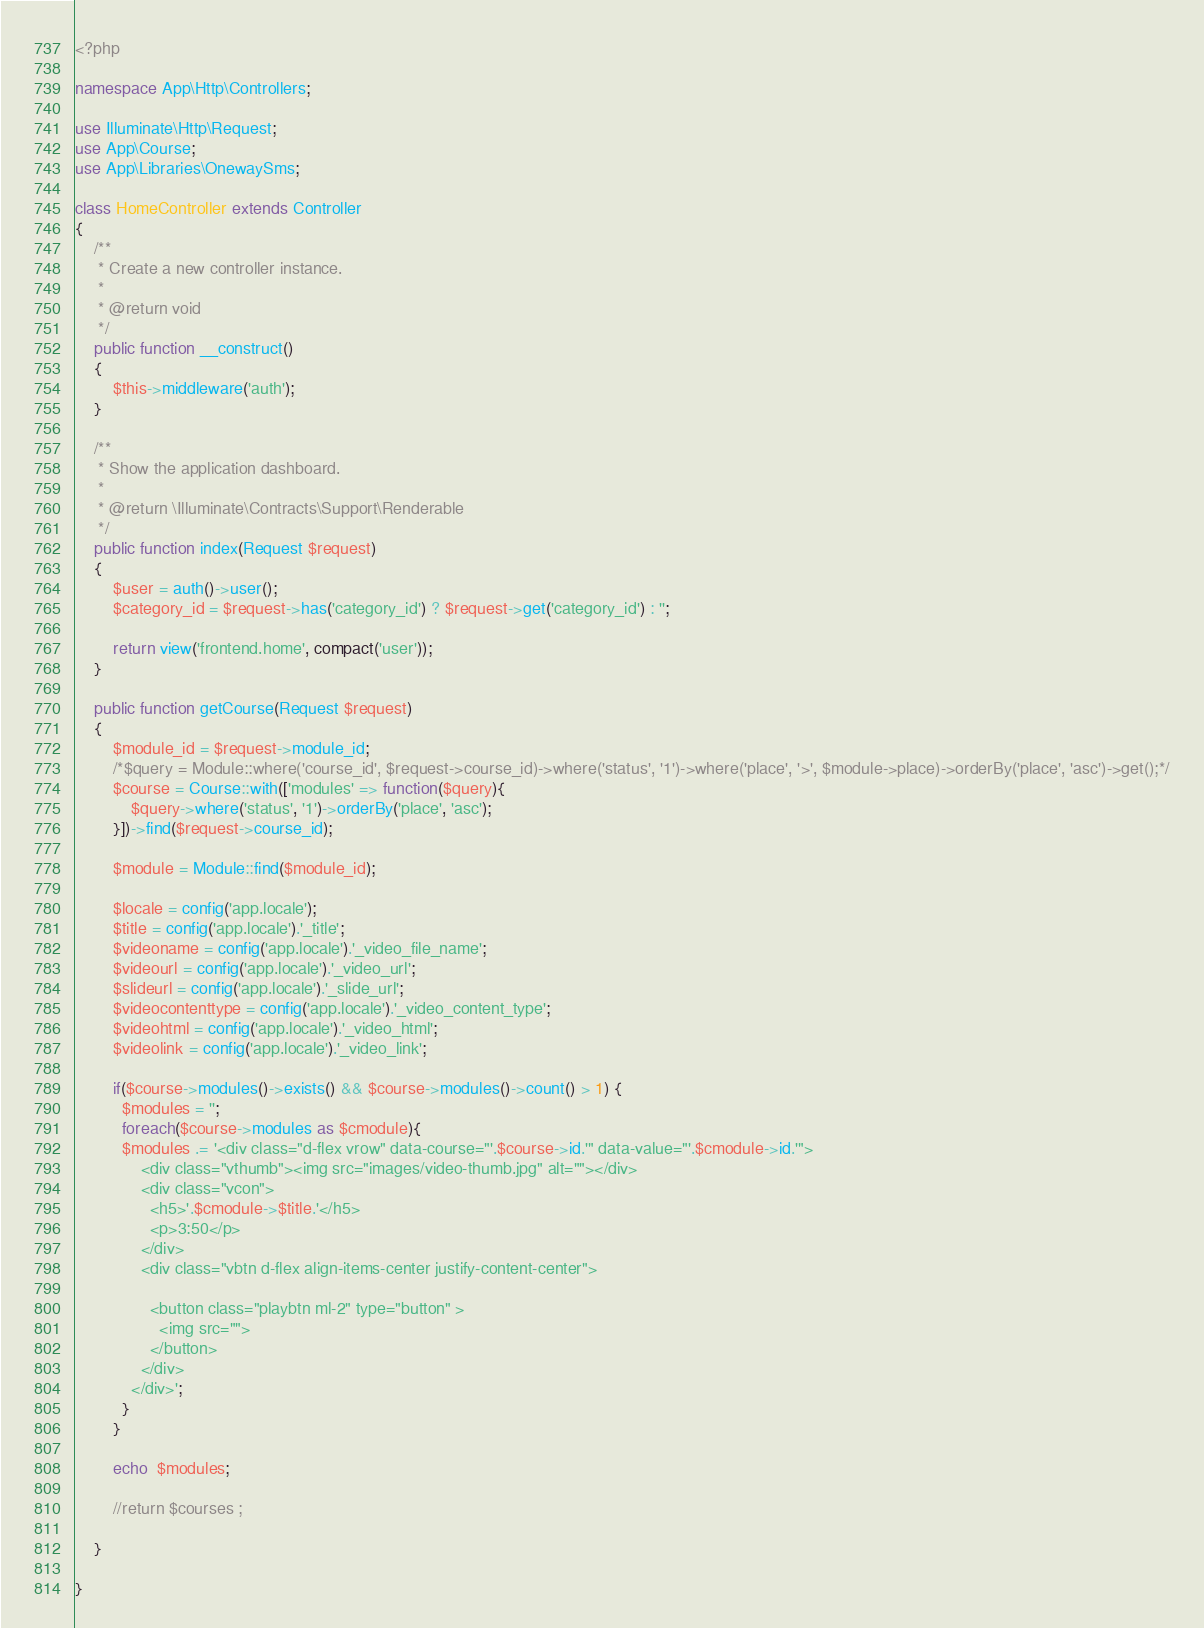Convert code to text. <code><loc_0><loc_0><loc_500><loc_500><_PHP_><?php

namespace App\Http\Controllers;

use Illuminate\Http\Request;
use App\Course;
use App\Libraries\OnewaySms;

class HomeController extends Controller
{
    /**
     * Create a new controller instance.
     *
     * @return void
     */
    public function __construct()
    {
        $this->middleware('auth');
    }

    /**
     * Show the application dashboard.
     *
     * @return \Illuminate\Contracts\Support\Renderable
     */
    public function index(Request $request)
    { 
        $user = auth()->user();
        $category_id = $request->has('category_id') ? $request->get('category_id') : '';
        
        return view('frontend.home', compact('user'));
    }

    public function getCourse(Request $request)
    {
        $module_id = $request->module_id;
        /*$query = Module::where('course_id', $request->course_id)->where('status', '1')->where('place', '>', $module->place)->orderBy('place', 'asc')->get();*/
        $course = Course::with(['modules' => function($query){
            $query->where('status', '1')->orderBy('place', 'asc');
        }])->find($request->course_id);

        $module = Module::find($module_id);

        $locale = config('app.locale');
        $title = config('app.locale').'_title';
        $videoname = config('app.locale').'_video_file_name';
        $videourl = config('app.locale').'_video_url';
        $slideurl = config('app.locale').'_slide_url';
        $videocontenttype = config('app.locale').'_video_content_type';
        $videohtml = config('app.locale').'_video_html';
        $videolink = config('app.locale').'_video_link';

        if($course->modules()->exists() && $course->modules()->count() > 1) {
          $modules = '';
          foreach($course->modules as $cmodule){
          $modules .= '<div class="d-flex vrow" data-course="'.$course->id.'" data-value="'.$cmodule->id.'">
              <div class="vthumb"><img src="images/video-thumb.jpg" alt=""></div>
              <div class="vcon">
                <h5>'.$cmodule->$title.'</h5>
                <p>3:50</p>
              </div>
              <div class="vbtn d-flex align-items-center justify-content-center">
                
                <button class="playbtn ml-2" type="button" >
                  <img src="">
                </button>
              </div>
            </div>';
          }
        }

        echo  $modules;

        //return $courses ;
         
    }

}
</code> 